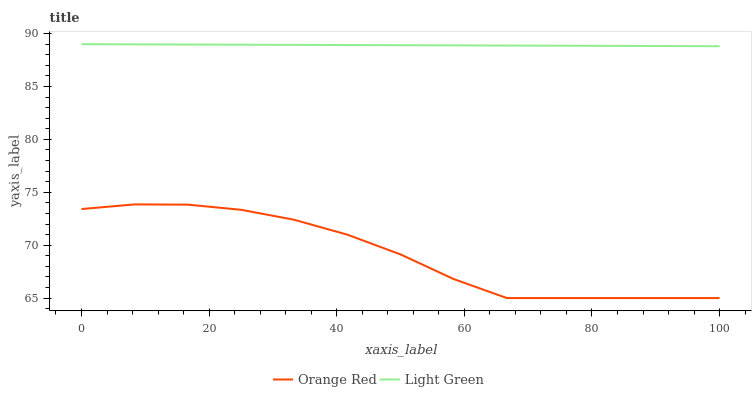Does Orange Red have the minimum area under the curve?
Answer yes or no. Yes. Does Light Green have the maximum area under the curve?
Answer yes or no. Yes. Does Light Green have the minimum area under the curve?
Answer yes or no. No. Is Light Green the smoothest?
Answer yes or no. Yes. Is Orange Red the roughest?
Answer yes or no. Yes. Is Light Green the roughest?
Answer yes or no. No. Does Orange Red have the lowest value?
Answer yes or no. Yes. Does Light Green have the lowest value?
Answer yes or no. No. Does Light Green have the highest value?
Answer yes or no. Yes. Is Orange Red less than Light Green?
Answer yes or no. Yes. Is Light Green greater than Orange Red?
Answer yes or no. Yes. Does Orange Red intersect Light Green?
Answer yes or no. No. 